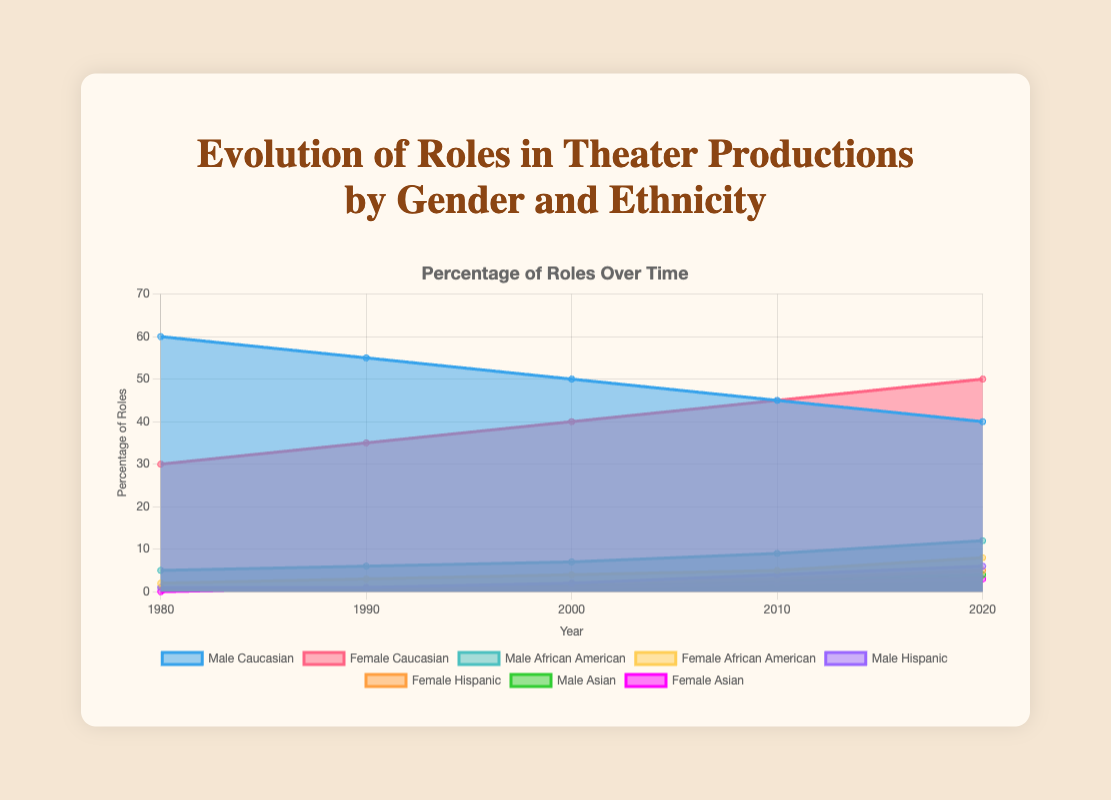What is the title of the chart? The title can be found at the top of the chart. It reads "Evolution of Roles in Theater Productions by Gender and Ethnicity".
Answer: Evolution of Roles in Theater Productions by Gender and Ethnicity How many ethnic groups are represented in the chart? The different color areas represent different ethnic groups, with 4 ethnic groups in total: Caucasian, African American, Hispanic, and Asian.
Answer: 4 Which group has the highest percentage of roles in 1980? By observing the chart at the year 1980, the section with the greatest height is 'Male Caucasian' at 60%.
Answer: Male Caucasian Which two groups saw the most significant increase in roles from 1980 to 2020? Reviewing the stack of both colors, 'Female Caucasian' increased from 30% to 50% and 'Female African American' increased from 2% to 8%. These are the most noticeable changes.
Answer: Female Caucasian, Female African American What was the percentage of Female Asian roles in 2000? Referring to the chart at the year 2000, the area corresponding to 'Female Asian' reveals a value of 1%.
Answer: 1% Between 2000 and 2020, which group showed a higher increase in roles: Male Hispanic or Male Asian? Comparing the percentages, Male Hispanic increased from 2% to 6%, while Male Asian increased from 2% to 4%. Thus, Male Hispanic saw a greater increase.
Answer: Male Hispanic By how much did the percentage of roles for Female Hispanic actors change from 1990 to 2020? In 1990, Female Hispanic is 1%. In 2020, it is 5%. The change is calculated as 5% - 1% = 4%.
Answer: 4% Which year had the highest percentage of roles for Female Caucasian actors? Observing the chart, the highest point for Female Caucasian is in 2020 at 50%.
Answer: 2020 How did the percentage of Male Caucasian roles change over the years? The percentages for Male Caucasian roles over the years are: 1980 (60%), 1990 (55%), 2000 (50%), 2010 (45%), and 2020 (40%). The roles consistently decreased.
Answer: Decreased What trend is observed in the percentage of Male African American roles over time? The chart indicates an upward trend: from 5% in 1980 to 12% in 2020, consistently increasing over the years.
Answer: Increasing 